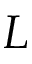Convert formula to latex. <formula><loc_0><loc_0><loc_500><loc_500>L</formula> 